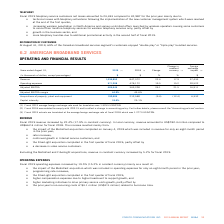According to Cogeco's financial document, What was the average exchange rate in 2019? According to the financial document, 1.3255 USD/CDN.. The relevant text states: "age foreign exchange rate used for translation was 1.3255 USD/CDN...." Also, What was the average exchange rate in 2018? According to the financial document, 1.2773 USD/CDN.. The relevant text states: "age foreign exchange rate of fiscal 2018 which was 1.2773 USD/CDN...." Also, What was the increase in the operating expenses in 2019? According to the financial document, 19.5%. The relevant text states: "Fiscal 2019 operating expenses increased by 19.5% (15.2% in constant currency) mainly as a result of:..." Also, can you calculate: What was the increase / (decrease) in the revenue from 2018 to 2019? Based on the calculation: 1,036,853 - 847,372, the result is 189481 (in thousands). This is based on the information: "Revenue 1,036,853 847,372 22.4 17.9 37,433 Revenue 1,036,853 847,372 22.4 17.9 37,433..." The key data points involved are: 1,036,853, 847,372. Also, can you calculate: What was the average operating expenses between 2018 and 2019? To answer this question, I need to perform calculations using the financial data. The calculation is: (571,208 + 478,172) / 2, which equals 524690 (in thousands). This is based on the information: "Operating expenses 571,208 478,172 19.5 15.2 20,522 Operating expenses 571,208 478,172 19.5 15.2 20,522..." The key data points involved are: 478,172, 571,208. Also, can you calculate: What was the increase / (decrease) in the Adjusted EBITDA from 2018 to 2019? Based on the calculation: 465,645 - 369,200, the result is 96445 (in thousands). This is based on the information: "Adjusted EBITDA 465,645 369,200 26.1 21.5 16,911 Adjusted EBITDA 465,645 369,200 26.1 21.5 16,911..." The key data points involved are: 369,200, 465,645. 